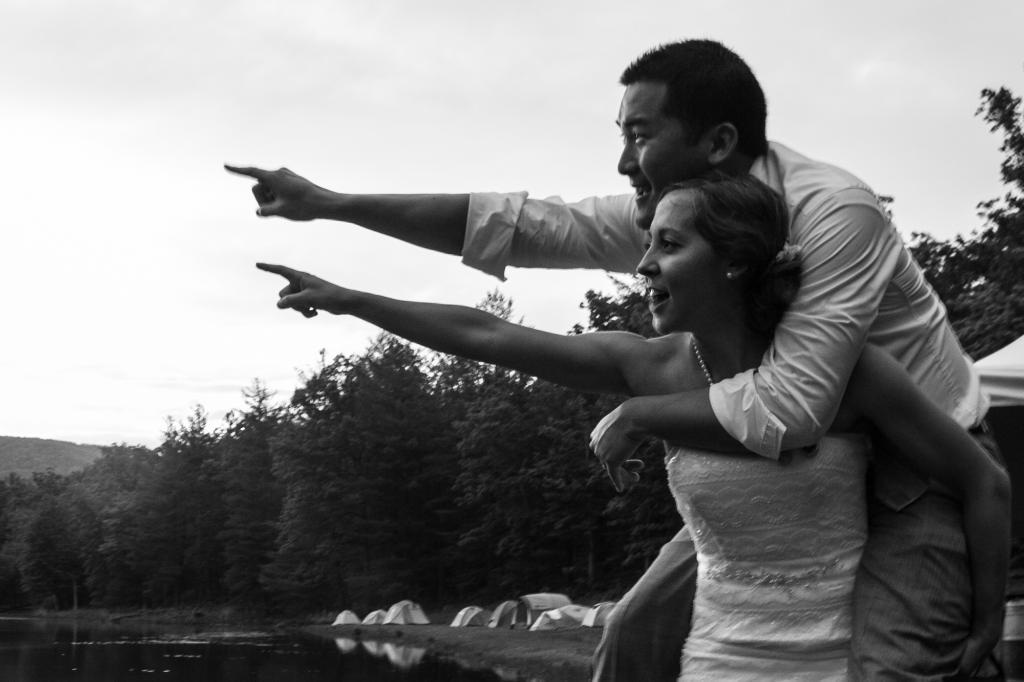How many people are present in the image? There is a woman and a man present in the image. What are the woman and man doing in the image? The woman and man are pointing towards the left side of the image. What can be seen in the background of the image? The sky is visible in the background of the image. What type of natural environment is visible in the image? There are trees and water visible in the image. What type of temporary shelter is present in the image? There are tents in the image. What type of fang can be seen in the image? There are no fangs present in the image. How many rooms are visible in the image? There is no room visible in the image; it is an outdoor scene with tents and trees. 